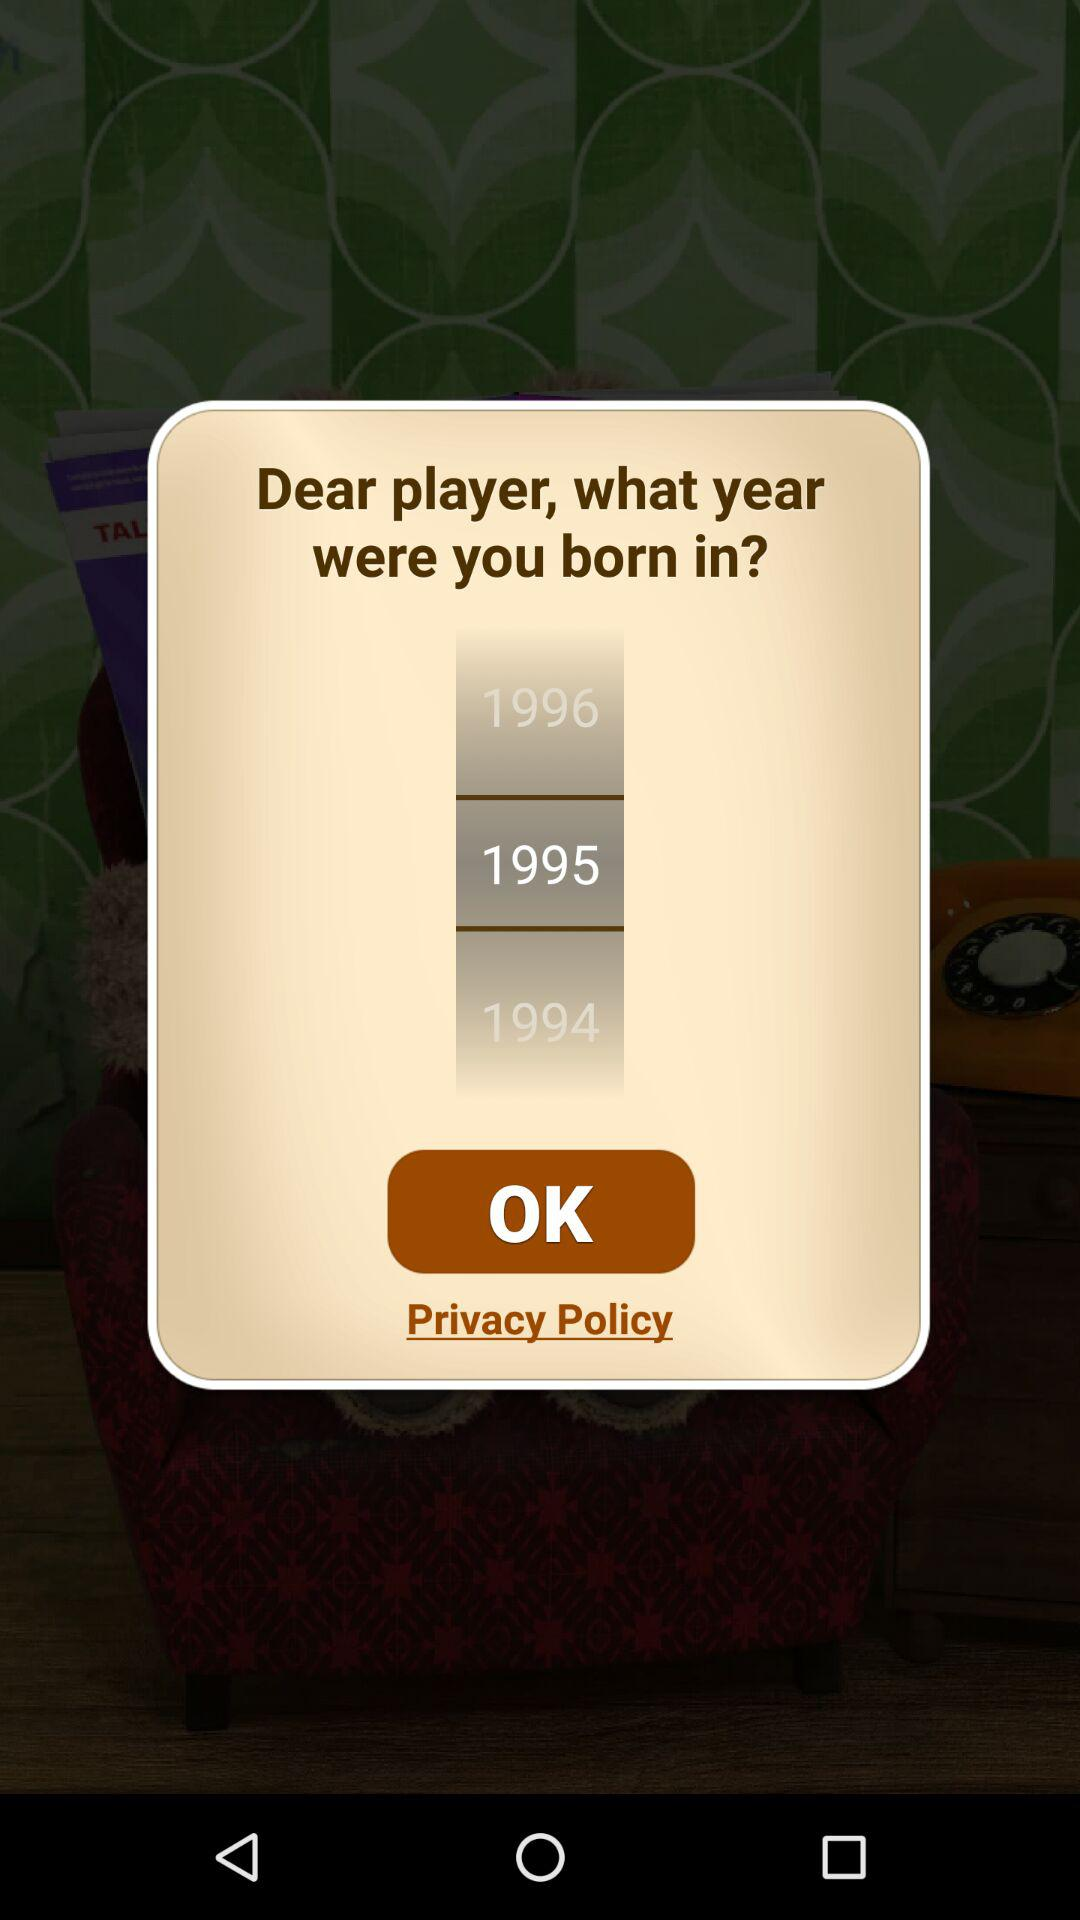How many birth years are displayed on this screen?
Answer the question using a single word or phrase. 3 